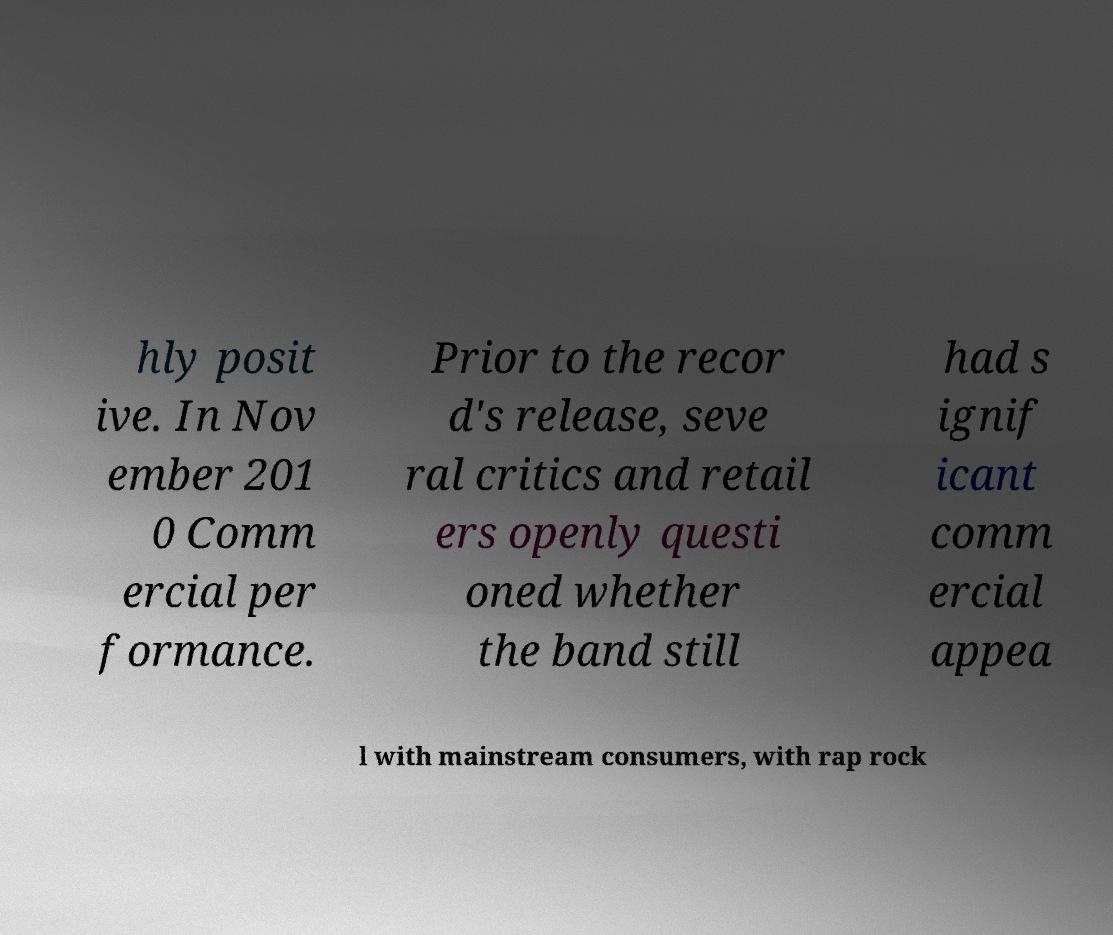Can you read and provide the text displayed in the image?This photo seems to have some interesting text. Can you extract and type it out for me? hly posit ive. In Nov ember 201 0 Comm ercial per formance. Prior to the recor d's release, seve ral critics and retail ers openly questi oned whether the band still had s ignif icant comm ercial appea l with mainstream consumers, with rap rock 